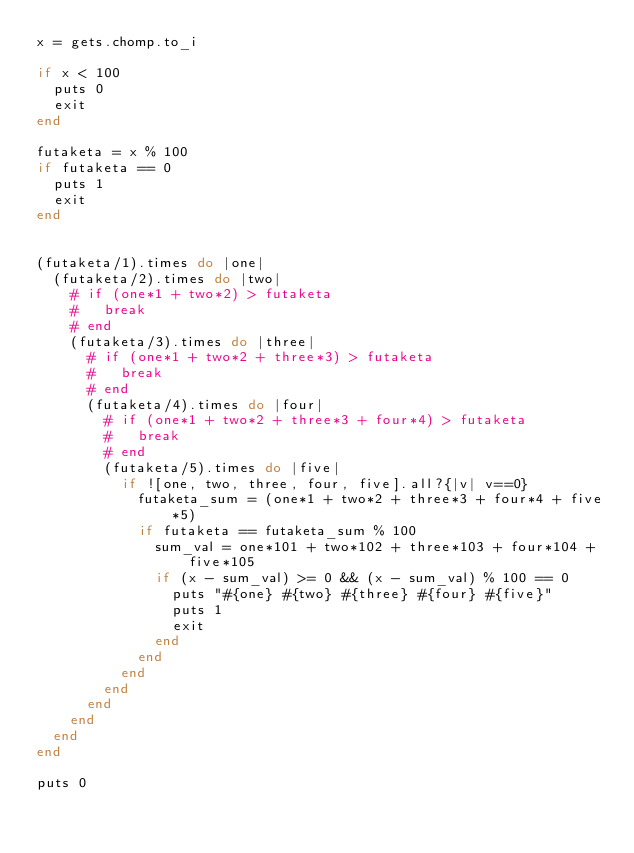Convert code to text. <code><loc_0><loc_0><loc_500><loc_500><_Ruby_>x = gets.chomp.to_i

if x < 100
  puts 0
  exit
end

futaketa = x % 100
if futaketa == 0
  puts 1
  exit
end


(futaketa/1).times do |one|
  (futaketa/2).times do |two|
    # if (one*1 + two*2) > futaketa
    #   break
    # end
    (futaketa/3).times do |three|
      # if (one*1 + two*2 + three*3) > futaketa
      #   break
      # end
      (futaketa/4).times do |four|
        # if (one*1 + two*2 + three*3 + four*4) > futaketa
        #   break
        # end
        (futaketa/5).times do |five|
          if ![one, two, three, four, five].all?{|v| v==0}
            futaketa_sum = (one*1 + two*2 + three*3 + four*4 + five*5)
            if futaketa == futaketa_sum % 100
              sum_val = one*101 + two*102 + three*103 + four*104 + five*105
              if (x - sum_val) >= 0 && (x - sum_val) % 100 == 0
                puts "#{one} #{two} #{three} #{four} #{five}"
                puts 1
                exit
              end
            end
          end
        end
      end
    end
  end
end

puts 0</code> 